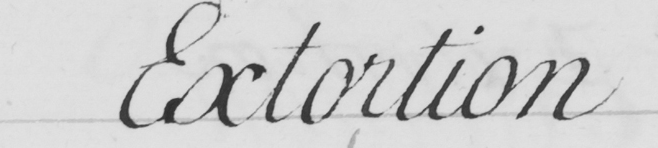What text is written in this handwritten line? Extortion 